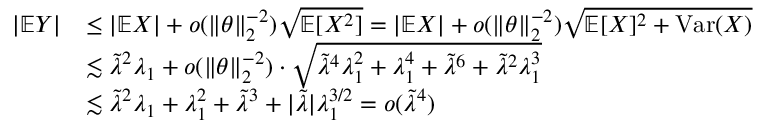Convert formula to latex. <formula><loc_0><loc_0><loc_500><loc_500>\begin{array} { r l } { | \mathbb { E } Y | } & { \leq | \mathbb { E } X | + o ( \| \theta \| _ { 2 } ^ { - 2 } ) \sqrt { \mathbb { E } [ X ^ { 2 } ] } = | \mathbb { E } X | + o ( \| \theta \| _ { 2 } ^ { - 2 } ) \sqrt { \mathbb { E } [ X ] ^ { 2 } + V a r ( X ) } } \\ & { \lesssim \tilde { \lambda } ^ { 2 } \lambda _ { 1 } + o ( \| \theta \| _ { 2 } ^ { - 2 } ) \cdot \sqrt { \tilde { \lambda } ^ { 4 } \lambda _ { 1 } ^ { 2 } + \lambda _ { 1 } ^ { 4 } + \tilde { \lambda } ^ { 6 } + \tilde { \lambda } ^ { 2 } \lambda _ { 1 } ^ { 3 } } } \\ & { \lesssim \tilde { \lambda } ^ { 2 } \lambda _ { 1 } + \lambda _ { 1 } ^ { 2 } + \tilde { \lambda } ^ { 3 } + | \tilde { \lambda } | \lambda _ { 1 } ^ { 3 / 2 } = o ( \tilde { \lambda } ^ { 4 } ) } \end{array}</formula> 